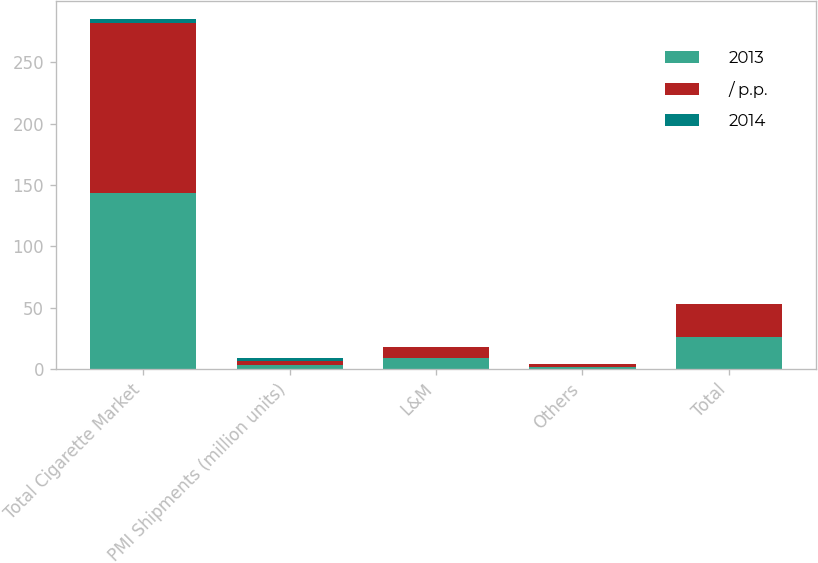<chart> <loc_0><loc_0><loc_500><loc_500><stacked_bar_chart><ecel><fcel>Total Cigarette Market<fcel>PMI Shipments (million units)<fcel>L&M<fcel>Others<fcel>Total<nl><fcel>2013<fcel>143.3<fcel>3.4<fcel>8.9<fcel>1.9<fcel>26.1<nl><fcel>/ p.p.<fcel>138.7<fcel>3.4<fcel>9.1<fcel>2.1<fcel>26.5<nl><fcel>2014<fcel>3.4<fcel>2.5<fcel>0.2<fcel>0.2<fcel>0.4<nl></chart> 